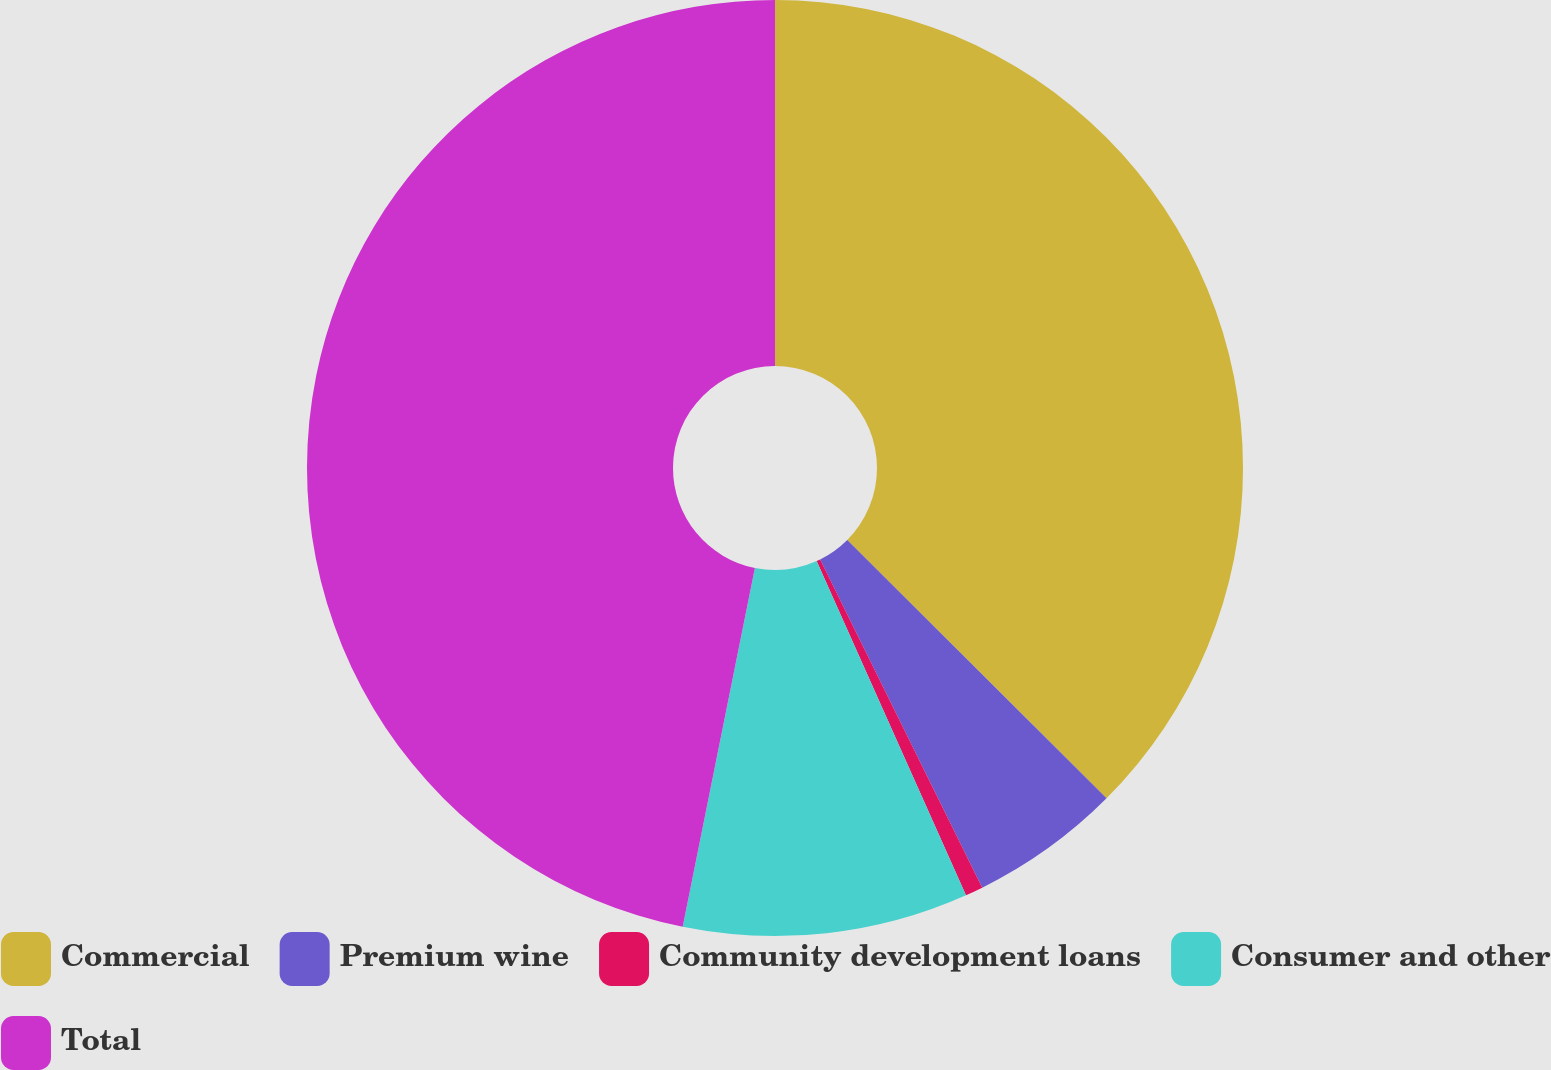Convert chart to OTSL. <chart><loc_0><loc_0><loc_500><loc_500><pie_chart><fcel>Commercial<fcel>Premium wine<fcel>Community development loans<fcel>Consumer and other<fcel>Total<nl><fcel>37.47%<fcel>5.23%<fcel>0.61%<fcel>9.85%<fcel>46.84%<nl></chart> 